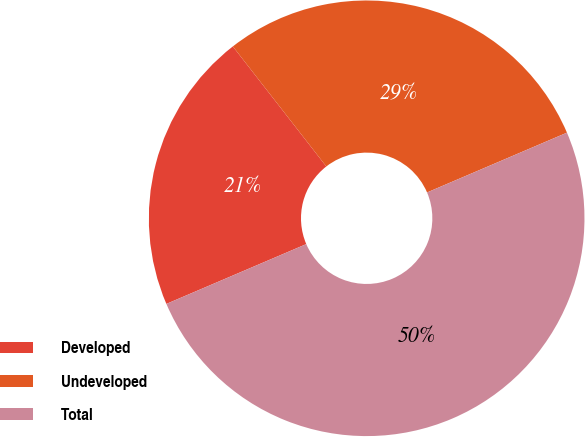Convert chart to OTSL. <chart><loc_0><loc_0><loc_500><loc_500><pie_chart><fcel>Developed<fcel>Undeveloped<fcel>Total<nl><fcel>20.9%<fcel>29.1%<fcel>50.0%<nl></chart> 